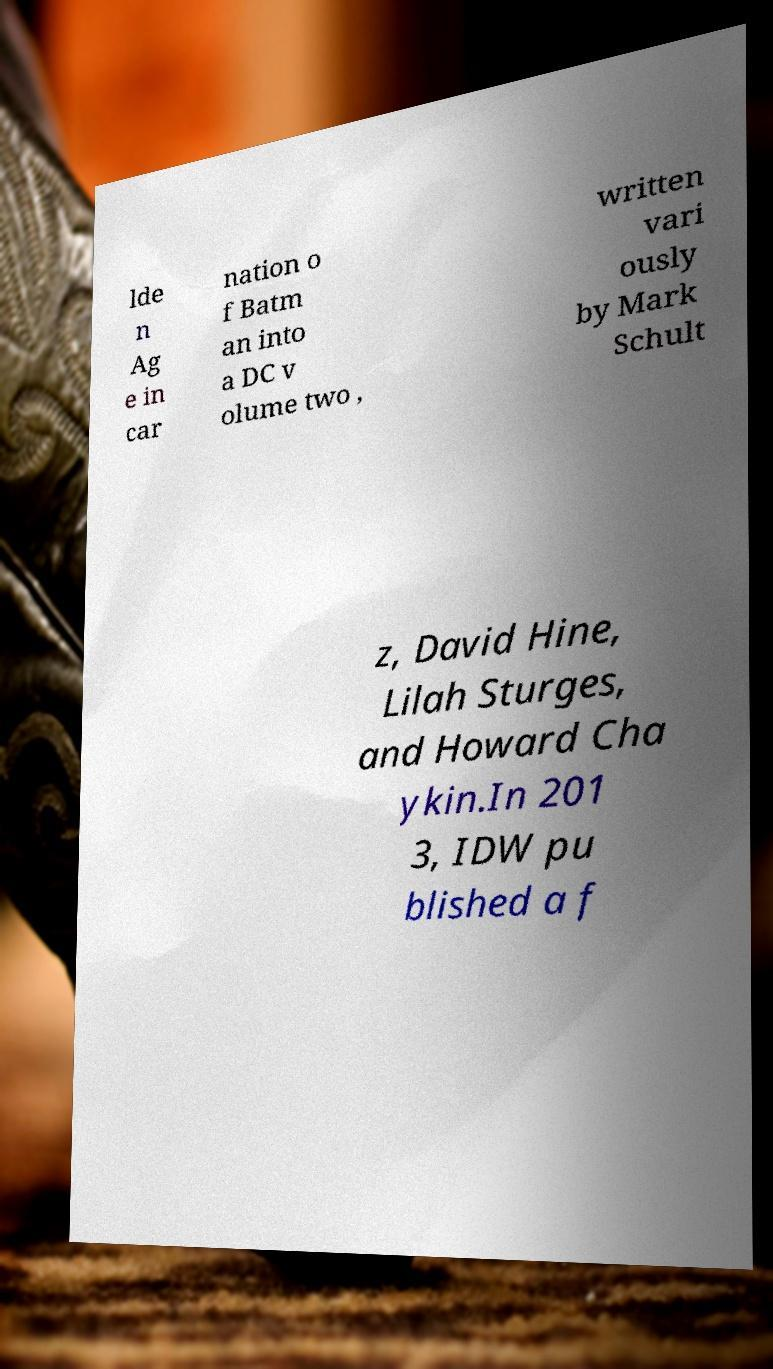Can you read and provide the text displayed in the image?This photo seems to have some interesting text. Can you extract and type it out for me? lde n Ag e in car nation o f Batm an into a DC v olume two , written vari ously by Mark Schult z, David Hine, Lilah Sturges, and Howard Cha ykin.In 201 3, IDW pu blished a f 